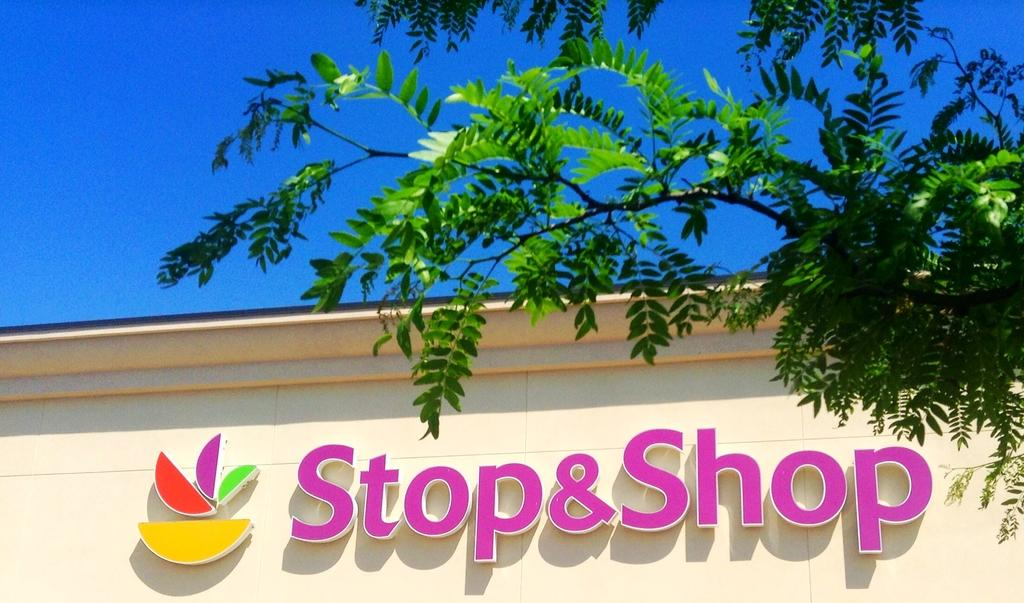What is on the wall in the image? There is a letters board on the wall in the image. What type of natural elements can be seen in the image? Branches and leaves are visible in the image. What can be seen in the background of the image? There is sky visible in the background of the image. How many snakes are crawling on the letters board in the image? There are no snakes present in the image; the letters board is the main subject on the wall. 